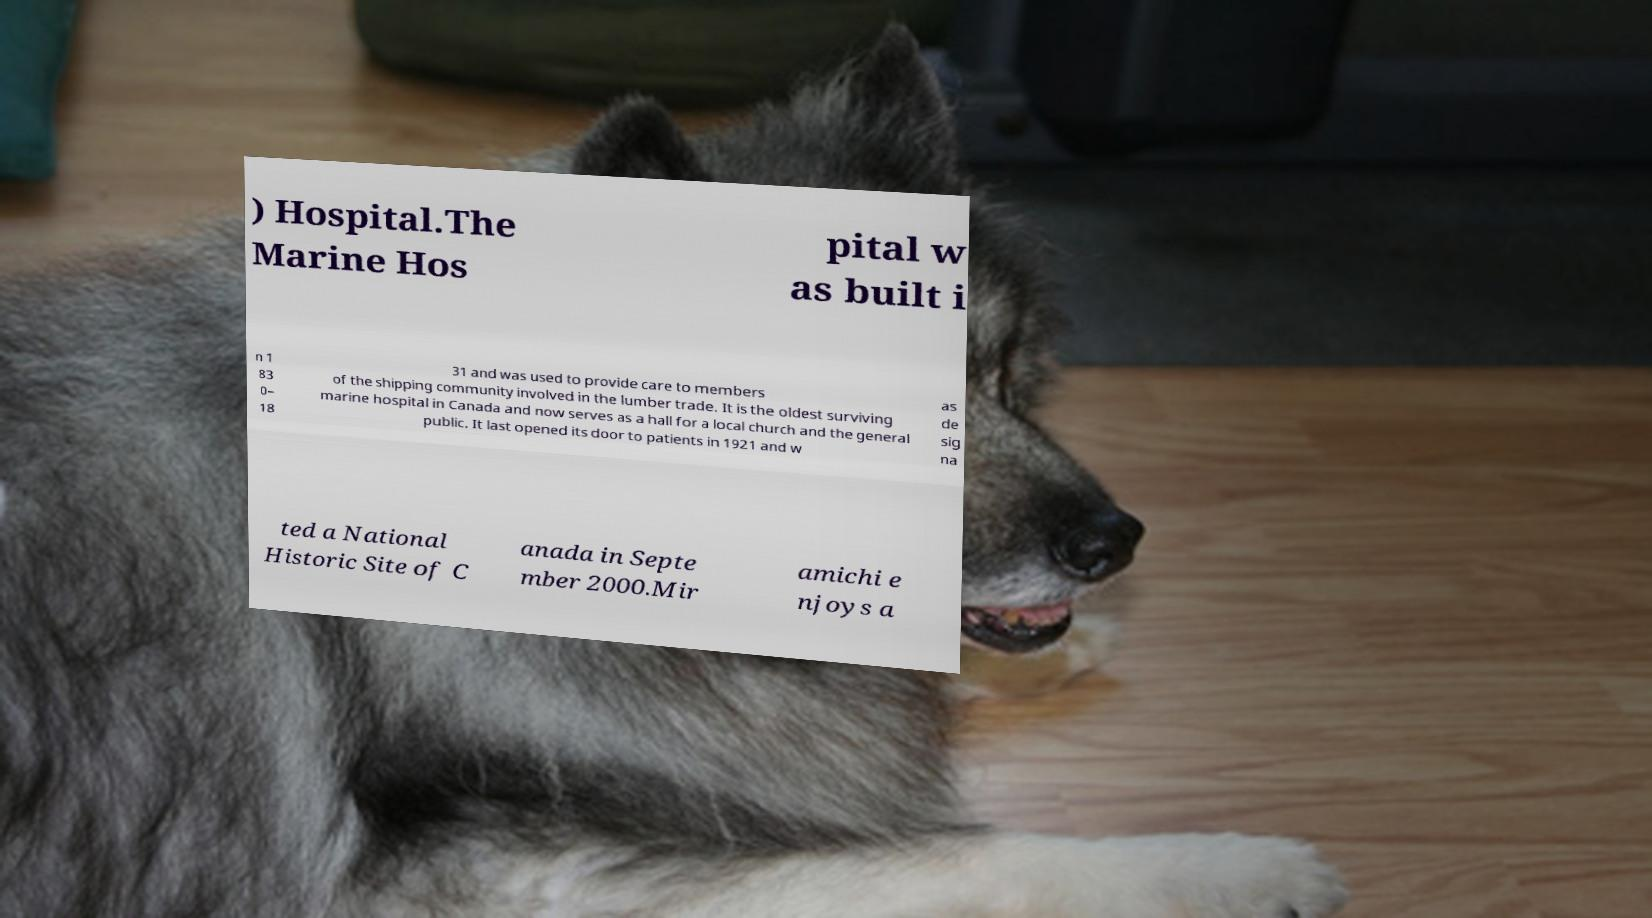Can you read and provide the text displayed in the image?This photo seems to have some interesting text. Can you extract and type it out for me? ) Hospital.The Marine Hos pital w as built i n 1 83 0– 18 31 and was used to provide care to members of the shipping community involved in the lumber trade. It is the oldest surviving marine hospital in Canada and now serves as a hall for a local church and the general public. It last opened its door to patients in 1921 and w as de sig na ted a National Historic Site of C anada in Septe mber 2000.Mir amichi e njoys a 